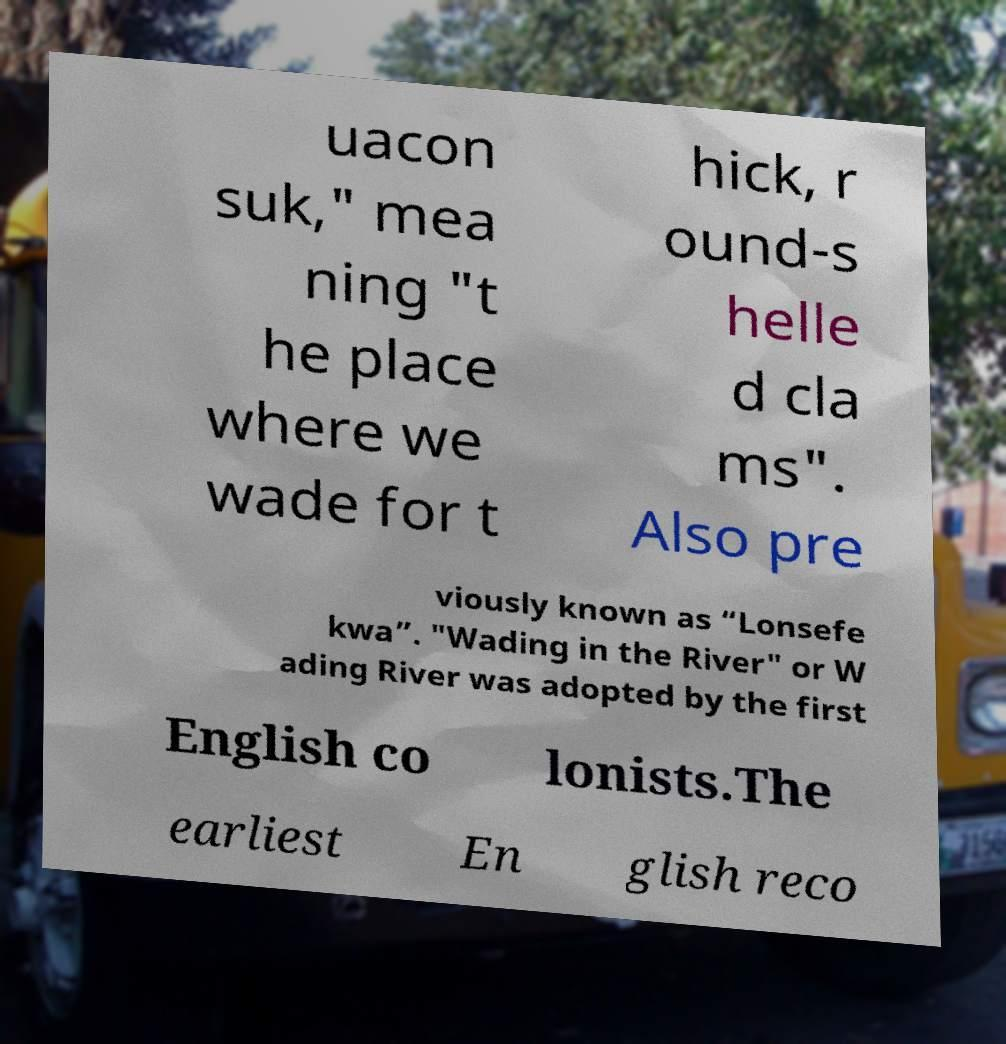Can you read and provide the text displayed in the image?This photo seems to have some interesting text. Can you extract and type it out for me? uacon suk," mea ning "t he place where we wade for t hick, r ound-s helle d cla ms". Also pre viously known as “Lonsefe kwa”. "Wading in the River" or W ading River was adopted by the first English co lonists.The earliest En glish reco 